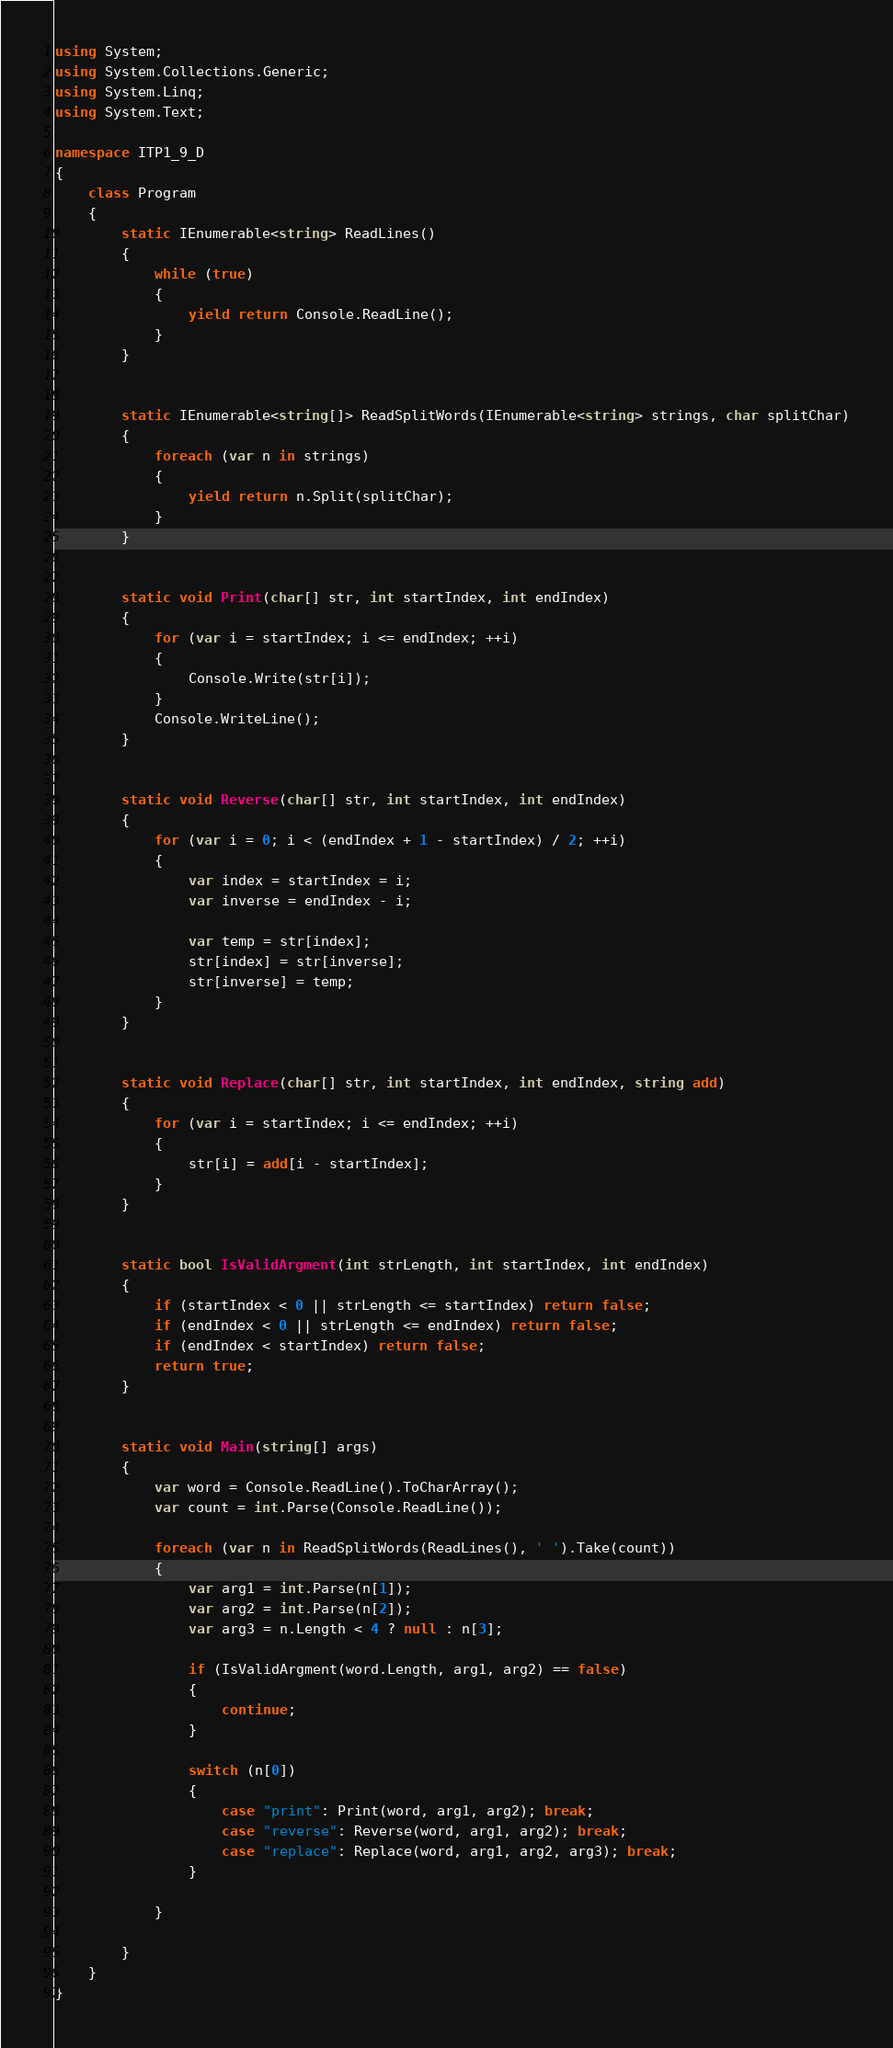Convert code to text. <code><loc_0><loc_0><loc_500><loc_500><_C#_>using System;
using System.Collections.Generic;
using System.Linq;
using System.Text;

namespace ITP1_9_D
{
    class Program
    {
        static IEnumerable<string> ReadLines()
        {
            while (true)
            {
                yield return Console.ReadLine();
            }
        }


        static IEnumerable<string[]> ReadSplitWords(IEnumerable<string> strings, char splitChar)
        {
            foreach (var n in strings)
            {
                yield return n.Split(splitChar);
            }                
        }


        static void Print(char[] str, int startIndex, int endIndex)
        {
            for (var i = startIndex; i <= endIndex; ++i)
            {
                Console.Write(str[i]);
            }
            Console.WriteLine();
        }


        static void Reverse(char[] str, int startIndex, int endIndex)
        {
            for (var i = 0; i < (endIndex + 1 - startIndex) / 2; ++i)
            {
                var index = startIndex = i;
                var inverse = endIndex - i;

                var temp = str[index];
                str[index] = str[inverse];
                str[inverse] = temp;
            }
        }


        static void Replace(char[] str, int startIndex, int endIndex, string add)
        {
            for (var i = startIndex; i <= endIndex; ++i)
            {
                str[i] = add[i - startIndex];
            }
        }


        static bool IsValidArgment(int strLength, int startIndex, int endIndex)
        {
            if (startIndex < 0 || strLength <= startIndex) return false;
            if (endIndex < 0 || strLength <= endIndex) return false;
            if (endIndex < startIndex) return false;
            return true;
        }


        static void Main(string[] args)
        {
            var word = Console.ReadLine().ToCharArray();
            var count = int.Parse(Console.ReadLine());

            foreach (var n in ReadSplitWords(ReadLines(), ' ').Take(count))
            {
                var arg1 = int.Parse(n[1]);
                var arg2 = int.Parse(n[2]);
                var arg3 = n.Length < 4 ? null : n[3];

                if (IsValidArgment(word.Length, arg1, arg2) == false)
                {
                    continue;
                }

                switch (n[0]) 
                {
                    case "print": Print(word, arg1, arg2); break;
                    case "reverse": Reverse(word, arg1, arg2); break;
                    case "replace": Replace(word, arg1, arg2, arg3); break;
                }

            }
            
        }
    }
}</code> 